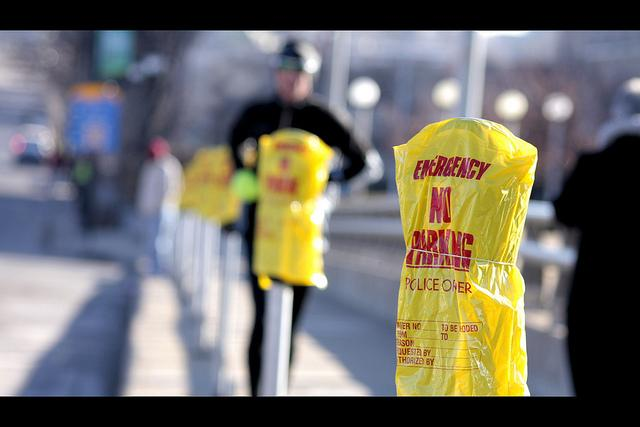What might be happening on this street?

Choices:
A) parade
B) fire
C) sale
D) rush hour parade 